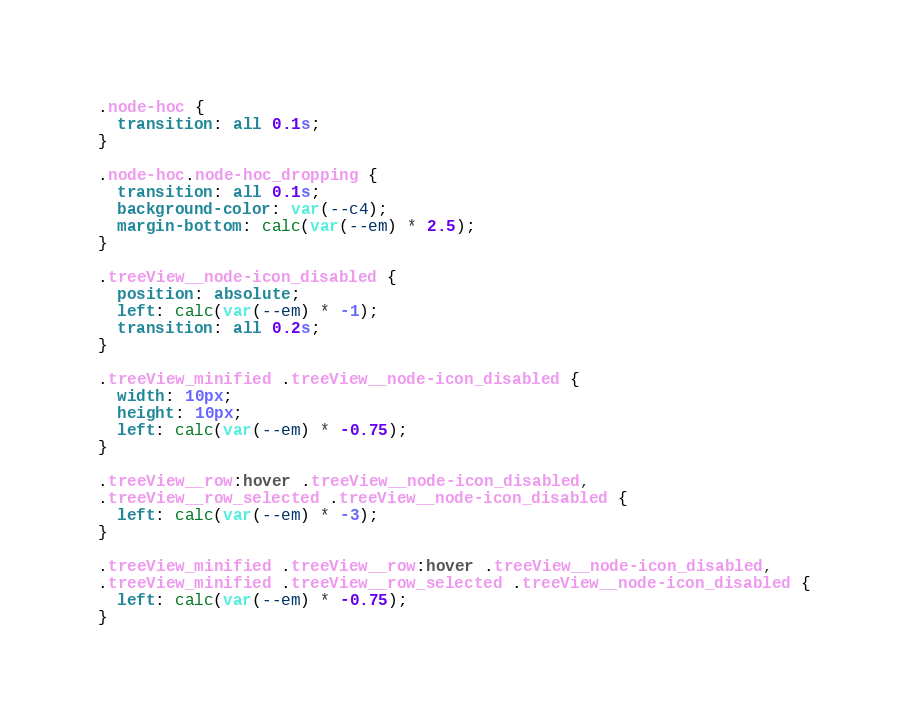<code> <loc_0><loc_0><loc_500><loc_500><_CSS_>.node-hoc {
  transition: all 0.1s;
}

.node-hoc.node-hoc_dropping {
  transition: all 0.1s;
  background-color: var(--c4);
  margin-bottom: calc(var(--em) * 2.5);
}

.treeView__node-icon_disabled {
  position: absolute;
  left: calc(var(--em) * -1);
  transition: all 0.2s;
}

.treeView_minified .treeView__node-icon_disabled {
  width: 10px;
  height: 10px;
  left: calc(var(--em) * -0.75);
}

.treeView__row:hover .treeView__node-icon_disabled,
.treeView__row_selected .treeView__node-icon_disabled {
  left: calc(var(--em) * -3);
}

.treeView_minified .treeView__row:hover .treeView__node-icon_disabled,
.treeView_minified .treeView__row_selected .treeView__node-icon_disabled {
  left: calc(var(--em) * -0.75);
}
</code> 